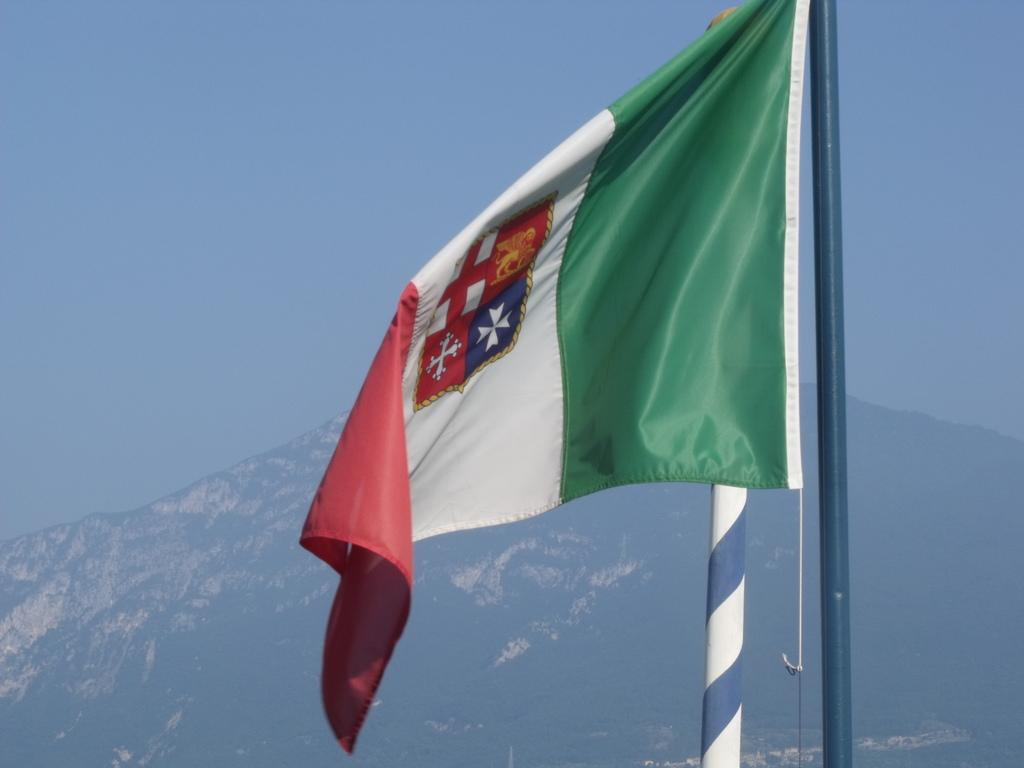What is on the pole in the image? There is a flag on a pole in the image. What type of natural environment can be seen in the image? There is greenery visible in the image. What can be seen in the distance in the image? There is a mountain covered with snow in the background of the image. What is visible above the flag and greenery in the image? The sky is visible in the image. Where can the mice be found in the image? There are no mice present in the image. What type of honey is being served in the lunchroom in the image? There is no lunchroom or honey present in the image. 